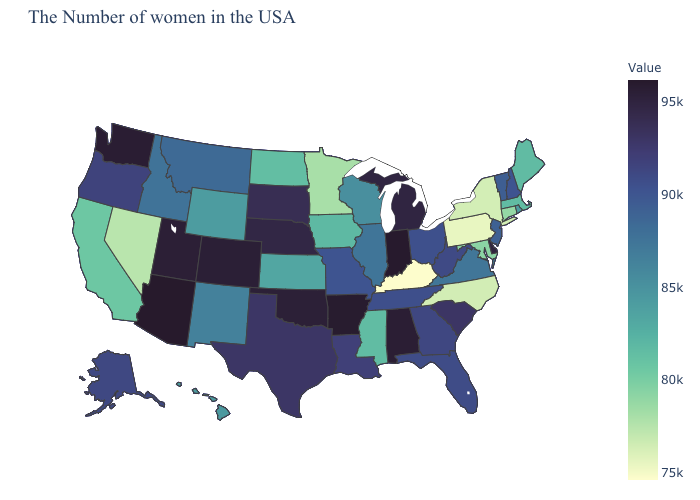Among the states that border Massachusetts , does Connecticut have the lowest value?
Concise answer only. No. Does Kentucky have the lowest value in the USA?
Be succinct. Yes. Does Michigan have the lowest value in the USA?
Quick response, please. No. Among the states that border California , which have the highest value?
Quick response, please. Arizona. 